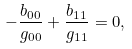Convert formula to latex. <formula><loc_0><loc_0><loc_500><loc_500>- \frac { b _ { 0 0 } } { g _ { 0 0 } } + \frac { b _ { 1 1 } } { g _ { 1 1 } } = 0 ,</formula> 